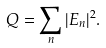<formula> <loc_0><loc_0><loc_500><loc_500>Q = \sum _ { n } | E _ { n } | ^ { 2 } .</formula> 